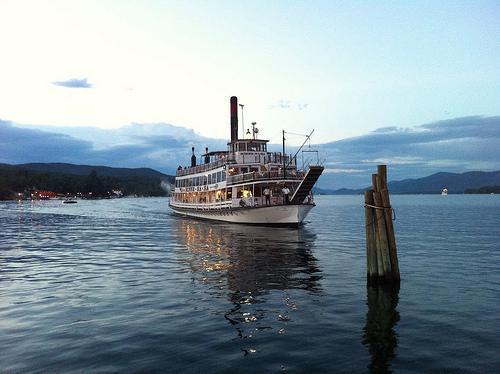How many boats are pictured here?
Give a very brief answer. 2. 